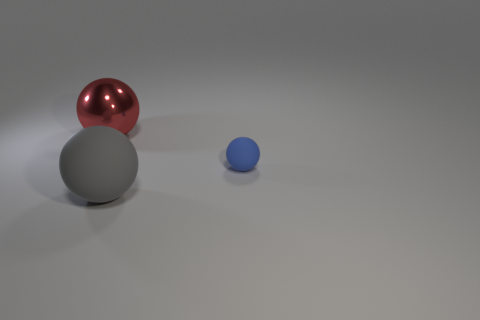Add 2 yellow metal cylinders. How many objects exist? 5 Subtract all big rubber things. Subtract all tiny rubber balls. How many objects are left? 1 Add 1 large things. How many large things are left? 3 Add 2 small cyan objects. How many small cyan objects exist? 2 Subtract 1 blue spheres. How many objects are left? 2 